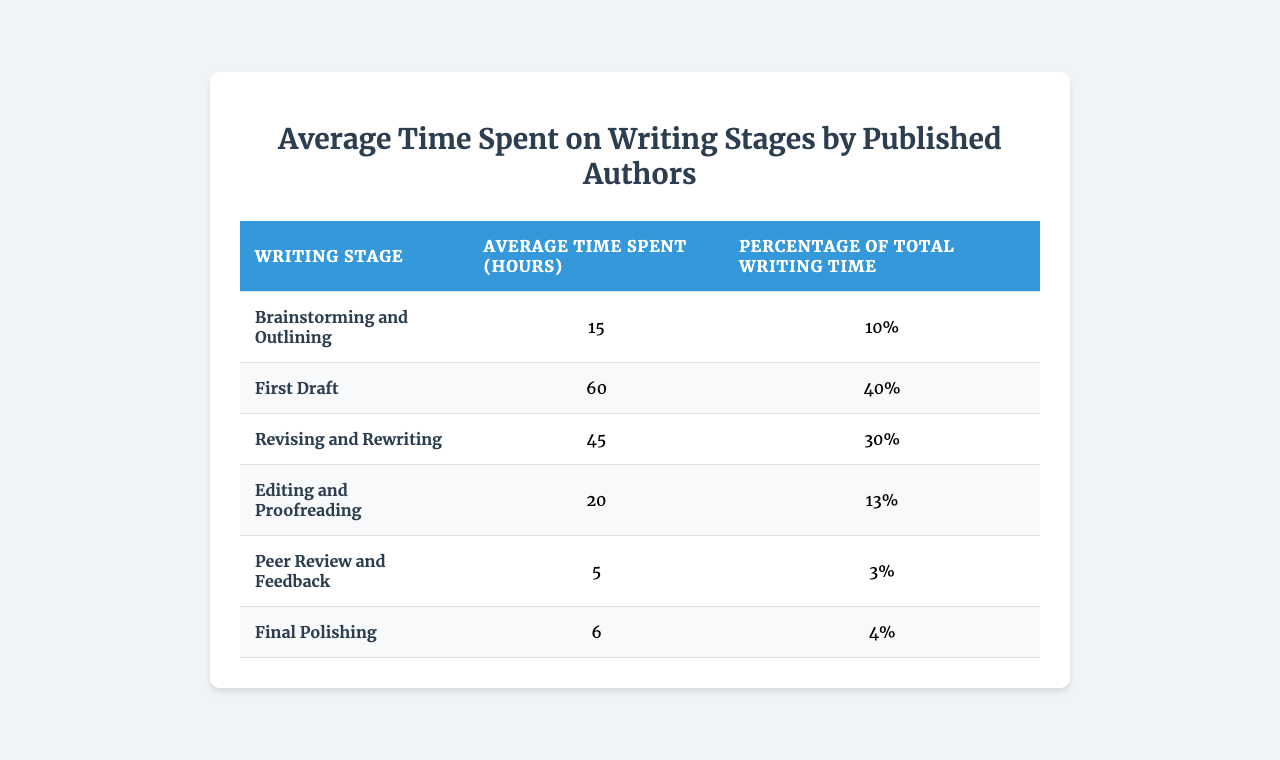What is the average time authors spend on brainstorming and outlining? According to the table, authors spend an average of 15 hours on brainstorming and outlining.
Answer: 15 hours Which writing stage takes the most time? The writing stage that takes the most time is the "First Draft," with an average of 60 hours spent.
Answer: First Draft What percentage of total writing time is spent on peer review and feedback? The table indicates that 3% of the total writing time is allocated to peer review and feedback.
Answer: 3% If the total writing time is 150 hours, how many hours do authors spend on "Editing and Proofreading"? To find out, we calculate 13% of 150 hours: (150 * 0.13) = 19.5 hours. Therefore, authors spend approximately 19.5 hours on "Editing and Proofreading."
Answer: 19.5 hours What is the combined average time spent on revising and rewriting, and editing and proofreading? To find the combined time, we add the average times for both stages: 45 hours (revising) + 20 hours (editing) = 65 hours.
Answer: 65 hours Is it true that more time is spent on the first draft than on editing and proofreading combined? Yes, it is true. The first draft takes 60 hours, while editing and proofreading together take 20 hours, making 80 hours in total for editing, which is still less than for the first draft.
Answer: True Which two writing stages combined require the least average time? Combining the average times for "Peer Review and Feedback" (5 hours) and "Final Polishing" (6 hours) gives a total of 11 hours, which is less than any other combination.
Answer: 11 hours What is the average time spent on the final polishing compared to the total average time across all stages? The total average time spent across stages is (15 + 60 + 45 + 20 + 5 + 6) = 151 hours. The average for final polishing is 6 hours, which is (6 / 151) * 100% ≈ 3.97% of the total time.
Answer: Approximately 4% 